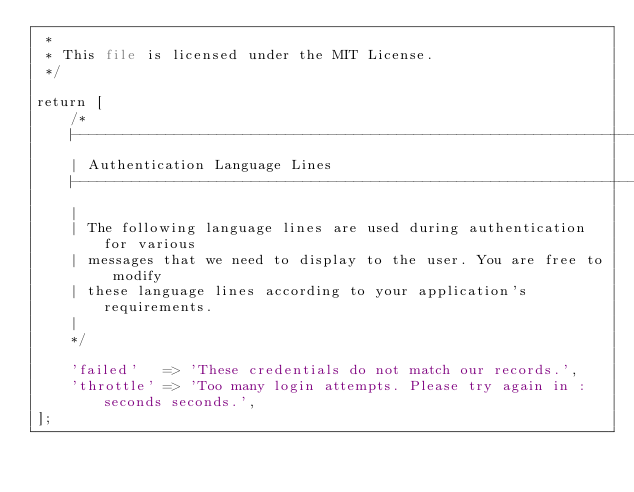Convert code to text. <code><loc_0><loc_0><loc_500><loc_500><_PHP_> *
 * This file is licensed under the MIT License.
 */

return [
    /*
    |--------------------------------------------------------------------------
    | Authentication Language Lines
    |--------------------------------------------------------------------------
    |
    | The following language lines are used during authentication for various
    | messages that we need to display to the user. You are free to modify
    | these language lines according to your application's requirements.
    |
    */

    'failed'   => 'These credentials do not match our records.',
    'throttle' => 'Too many login attempts. Please try again in :seconds seconds.',
];
</code> 